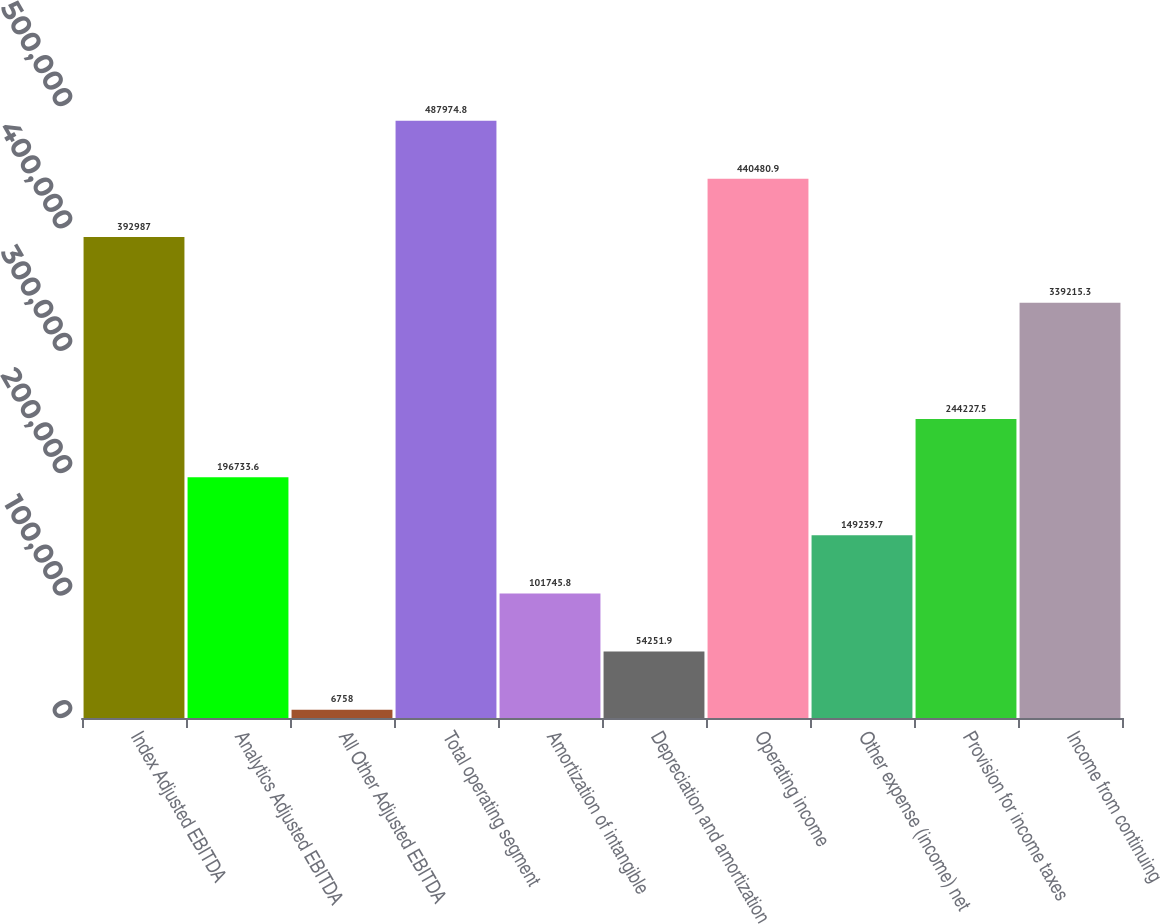Convert chart. <chart><loc_0><loc_0><loc_500><loc_500><bar_chart><fcel>Index Adjusted EBITDA<fcel>Analytics Adjusted EBITDA<fcel>All Other Adjusted EBITDA<fcel>Total operating segment<fcel>Amortization of intangible<fcel>Depreciation and amortization<fcel>Operating income<fcel>Other expense (income) net<fcel>Provision for income taxes<fcel>Income from continuing<nl><fcel>392987<fcel>196734<fcel>6758<fcel>487975<fcel>101746<fcel>54251.9<fcel>440481<fcel>149240<fcel>244228<fcel>339215<nl></chart> 